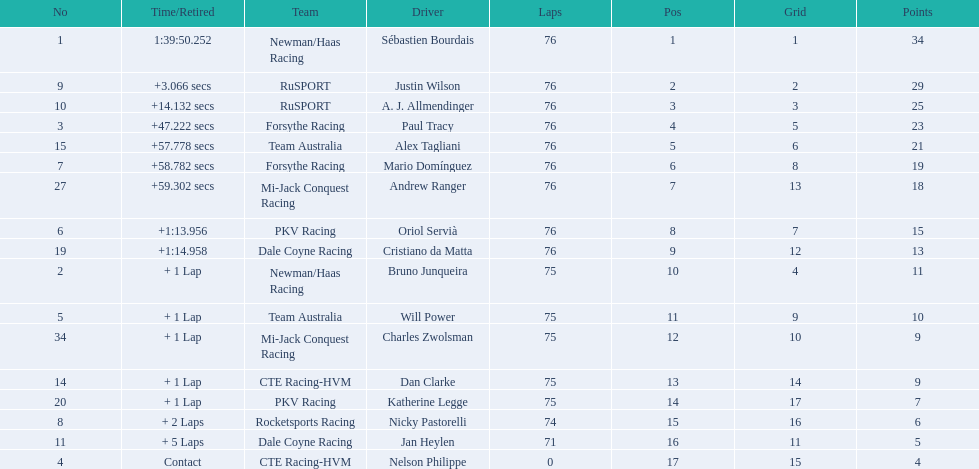Who drove during the 2006 tecate grand prix of monterrey? Sébastien Bourdais, Justin Wilson, A. J. Allmendinger, Paul Tracy, Alex Tagliani, Mario Domínguez, Andrew Ranger, Oriol Servià, Cristiano da Matta, Bruno Junqueira, Will Power, Charles Zwolsman, Dan Clarke, Katherine Legge, Nicky Pastorelli, Jan Heylen, Nelson Philippe. And what were their finishing positions? 1, 2, 3, 4, 5, 6, 7, 8, 9, 10, 11, 12, 13, 14, 15, 16, 17. Who did alex tagliani finish directly behind of? Paul Tracy. 